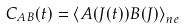<formula> <loc_0><loc_0><loc_500><loc_500>C _ { A B } ( t ) = \left \langle A ( J ( t ) ) B ( J ) \right \rangle _ { n e }</formula> 